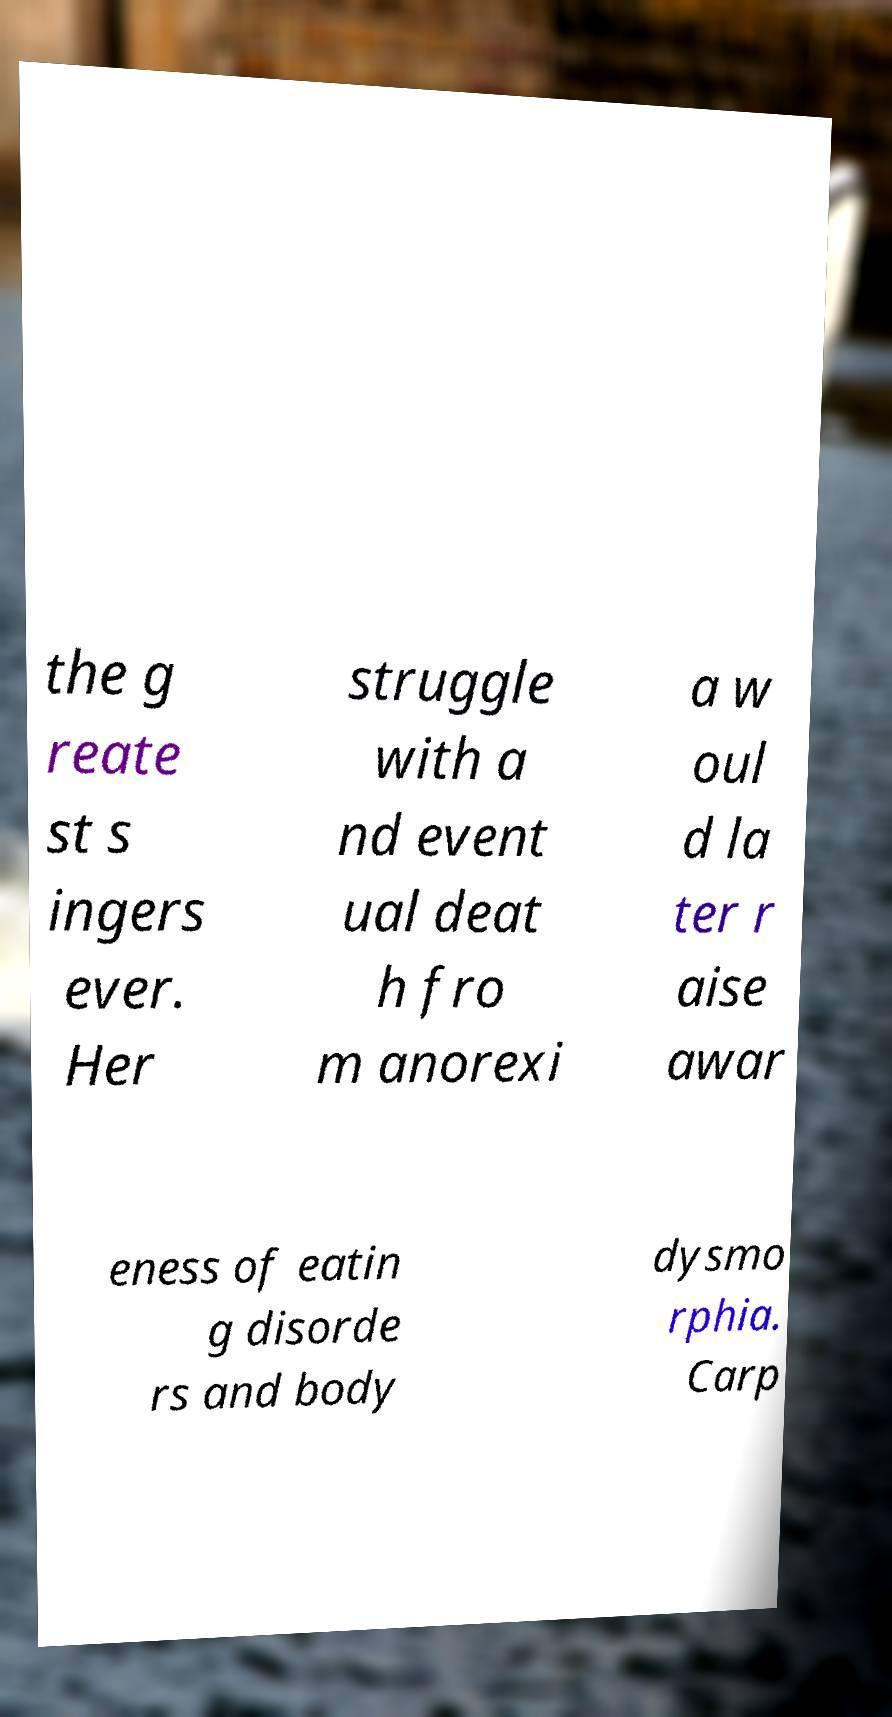Could you extract and type out the text from this image? the g reate st s ingers ever. Her struggle with a nd event ual deat h fro m anorexi a w oul d la ter r aise awar eness of eatin g disorde rs and body dysmo rphia. Carp 